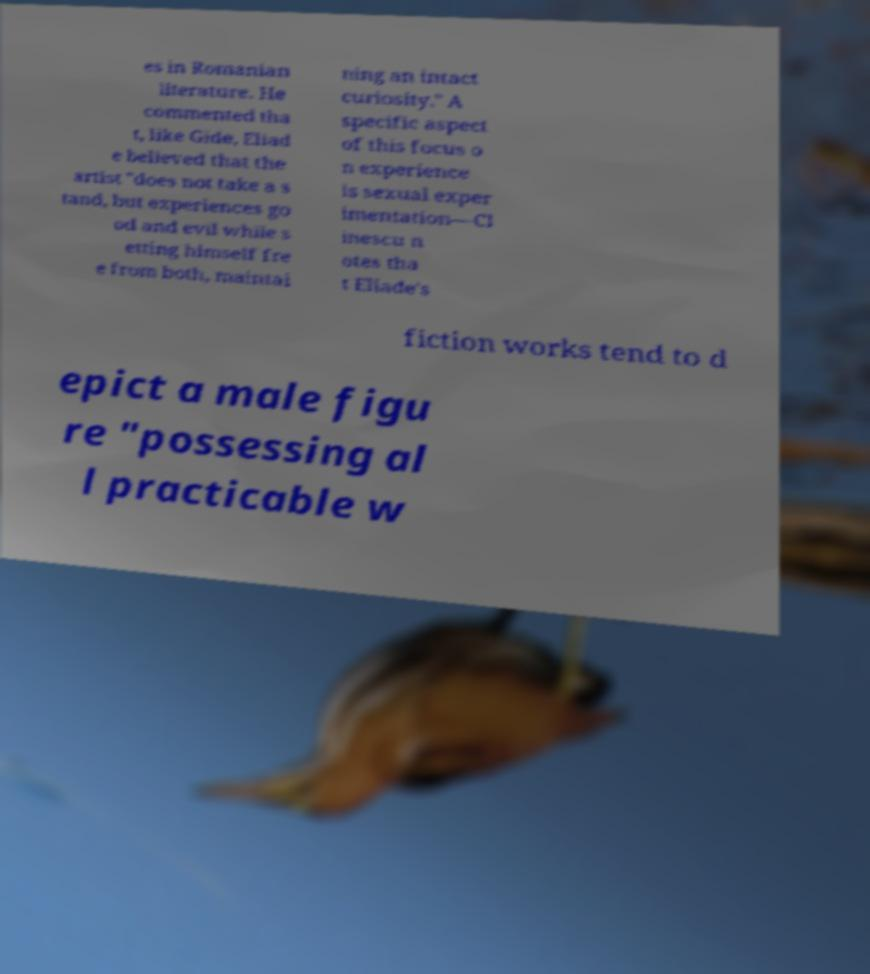I need the written content from this picture converted into text. Can you do that? es in Romanian literature. He commented tha t, like Gide, Eliad e believed that the artist "does not take a s tand, but experiences go od and evil while s etting himself fre e from both, maintai ning an intact curiosity." A specific aspect of this focus o n experience is sexual exper imentation—Cl inescu n otes tha t Eliade's fiction works tend to d epict a male figu re "possessing al l practicable w 